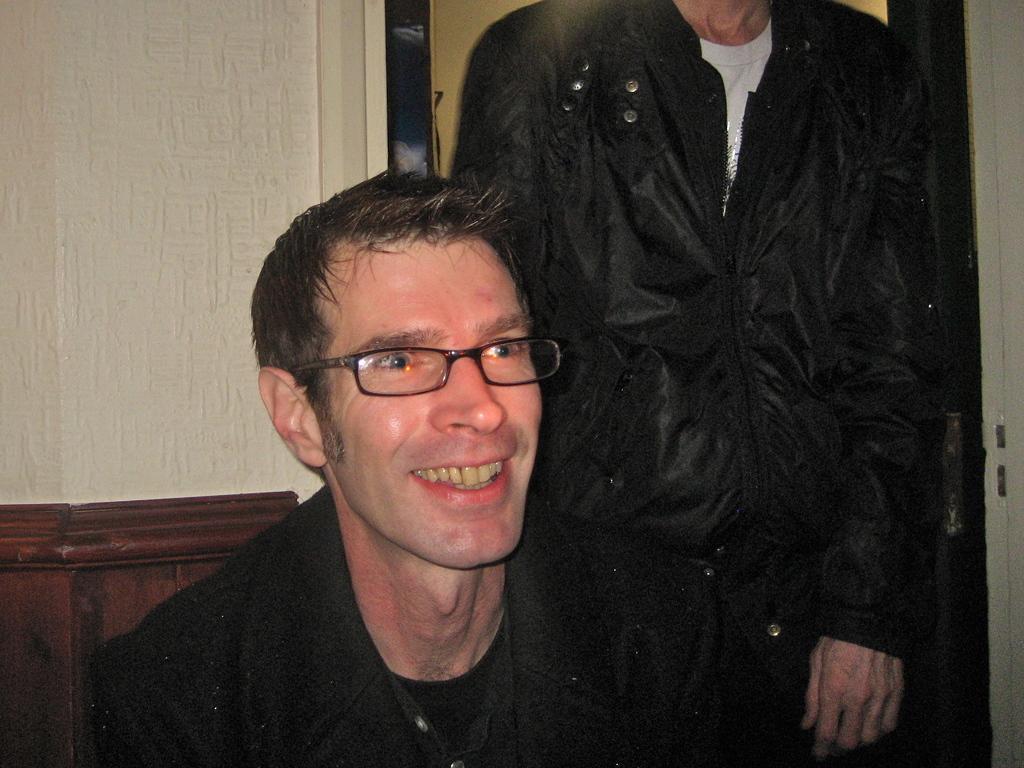How would you summarize this image in a sentence or two? At the bottom of the image I can see a man wearing black color dress, smiling and looking at the right side. At the back of this man I can see another man wearing black color jacket and standing and also I can see a wall. 